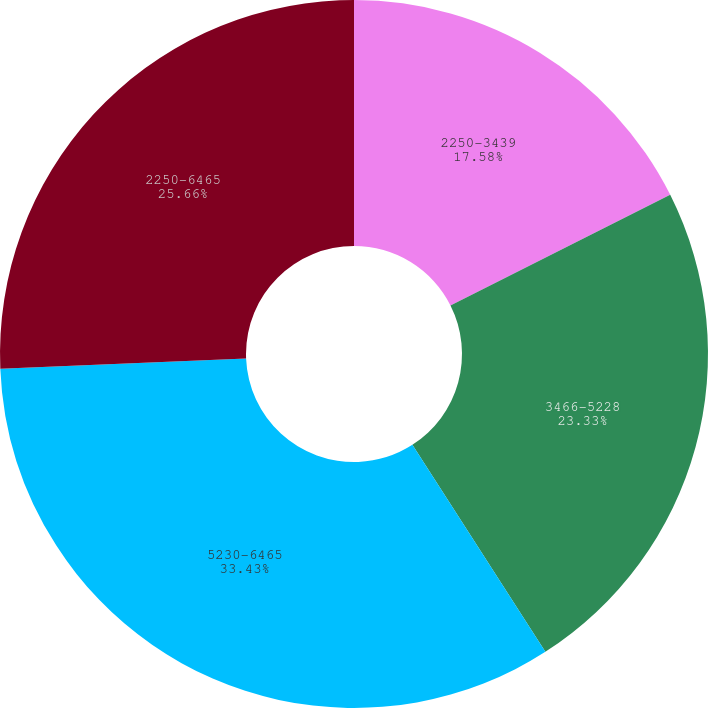<chart> <loc_0><loc_0><loc_500><loc_500><pie_chart><fcel>2250-3439<fcel>3466-5228<fcel>5230-6465<fcel>2250-6465<nl><fcel>17.58%<fcel>23.33%<fcel>33.43%<fcel>25.66%<nl></chart> 